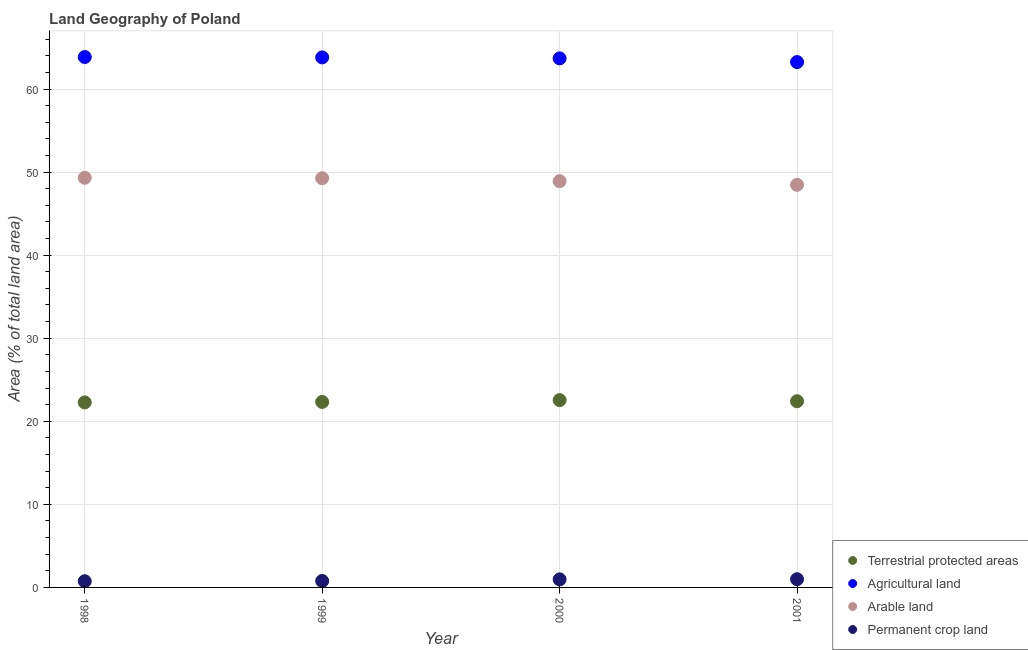How many different coloured dotlines are there?
Give a very brief answer. 4. Is the number of dotlines equal to the number of legend labels?
Your answer should be compact. Yes. What is the percentage of area under agricultural land in 1998?
Keep it short and to the point. 63.85. Across all years, what is the maximum percentage of area under arable land?
Your answer should be compact. 49.31. Across all years, what is the minimum percentage of area under permanent crop land?
Provide a short and direct response. 0.75. In which year was the percentage of area under permanent crop land maximum?
Your answer should be compact. 2001. What is the total percentage of area under agricultural land in the graph?
Provide a succinct answer. 254.59. What is the difference between the percentage of land under terrestrial protection in 1998 and that in 1999?
Offer a terse response. -0.06. What is the difference between the percentage of area under arable land in 2001 and the percentage of area under agricultural land in 1998?
Ensure brevity in your answer.  -15.39. What is the average percentage of area under arable land per year?
Keep it short and to the point. 48.99. In the year 2000, what is the difference between the percentage of area under arable land and percentage of area under permanent crop land?
Offer a terse response. 47.94. In how many years, is the percentage of area under permanent crop land greater than 58 %?
Your answer should be compact. 0. What is the ratio of the percentage of land under terrestrial protection in 1998 to that in 2000?
Your answer should be very brief. 0.99. Is the percentage of area under agricultural land in 1999 less than that in 2000?
Your answer should be compact. No. Is the difference between the percentage of land under terrestrial protection in 1998 and 2001 greater than the difference between the percentage of area under arable land in 1998 and 2001?
Your answer should be very brief. No. What is the difference between the highest and the second highest percentage of area under permanent crop land?
Offer a very short reply. 0.02. What is the difference between the highest and the lowest percentage of area under arable land?
Your answer should be very brief. 0.85. Is it the case that in every year, the sum of the percentage of land under terrestrial protection and percentage of area under arable land is greater than the sum of percentage of area under agricultural land and percentage of area under permanent crop land?
Make the answer very short. No. Is it the case that in every year, the sum of the percentage of land under terrestrial protection and percentage of area under agricultural land is greater than the percentage of area under arable land?
Offer a very short reply. Yes. Does the percentage of land under terrestrial protection monotonically increase over the years?
Offer a terse response. No. Is the percentage of land under terrestrial protection strictly less than the percentage of area under permanent crop land over the years?
Offer a very short reply. No. How many dotlines are there?
Provide a succinct answer. 4. What is the difference between two consecutive major ticks on the Y-axis?
Provide a succinct answer. 10. Does the graph contain any zero values?
Provide a short and direct response. No. What is the title of the graph?
Keep it short and to the point. Land Geography of Poland. What is the label or title of the X-axis?
Keep it short and to the point. Year. What is the label or title of the Y-axis?
Offer a terse response. Area (% of total land area). What is the Area (% of total land area) in Terrestrial protected areas in 1998?
Your response must be concise. 22.27. What is the Area (% of total land area) in Agricultural land in 1998?
Keep it short and to the point. 63.85. What is the Area (% of total land area) of Arable land in 1998?
Provide a short and direct response. 49.31. What is the Area (% of total land area) of Permanent crop land in 1998?
Give a very brief answer. 0.75. What is the Area (% of total land area) in Terrestrial protected areas in 1999?
Your response must be concise. 22.33. What is the Area (% of total land area) in Agricultural land in 1999?
Your answer should be compact. 63.81. What is the Area (% of total land area) of Arable land in 1999?
Ensure brevity in your answer.  49.26. What is the Area (% of total land area) in Permanent crop land in 1999?
Keep it short and to the point. 0.78. What is the Area (% of total land area) in Terrestrial protected areas in 2000?
Offer a very short reply. 22.55. What is the Area (% of total land area) of Agricultural land in 2000?
Your response must be concise. 63.69. What is the Area (% of total land area) in Arable land in 2000?
Your answer should be compact. 48.91. What is the Area (% of total land area) of Permanent crop land in 2000?
Your answer should be very brief. 0.97. What is the Area (% of total land area) in Terrestrial protected areas in 2001?
Ensure brevity in your answer.  22.41. What is the Area (% of total land area) in Agricultural land in 2001?
Offer a very short reply. 63.24. What is the Area (% of total land area) of Arable land in 2001?
Provide a succinct answer. 48.46. What is the Area (% of total land area) of Permanent crop land in 2001?
Your response must be concise. 0.99. Across all years, what is the maximum Area (% of total land area) of Terrestrial protected areas?
Your answer should be very brief. 22.55. Across all years, what is the maximum Area (% of total land area) in Agricultural land?
Offer a very short reply. 63.85. Across all years, what is the maximum Area (% of total land area) in Arable land?
Give a very brief answer. 49.31. Across all years, what is the maximum Area (% of total land area) of Permanent crop land?
Ensure brevity in your answer.  0.99. Across all years, what is the minimum Area (% of total land area) of Terrestrial protected areas?
Provide a short and direct response. 22.27. Across all years, what is the minimum Area (% of total land area) of Agricultural land?
Offer a very short reply. 63.24. Across all years, what is the minimum Area (% of total land area) of Arable land?
Your answer should be very brief. 48.46. Across all years, what is the minimum Area (% of total land area) in Permanent crop land?
Provide a short and direct response. 0.75. What is the total Area (% of total land area) of Terrestrial protected areas in the graph?
Ensure brevity in your answer.  89.57. What is the total Area (% of total land area) in Agricultural land in the graph?
Provide a succinct answer. 254.59. What is the total Area (% of total land area) of Arable land in the graph?
Offer a terse response. 195.94. What is the total Area (% of total land area) in Permanent crop land in the graph?
Provide a succinct answer. 3.48. What is the difference between the Area (% of total land area) of Terrestrial protected areas in 1998 and that in 1999?
Provide a short and direct response. -0.06. What is the difference between the Area (% of total land area) in Agricultural land in 1998 and that in 1999?
Give a very brief answer. 0.05. What is the difference between the Area (% of total land area) in Arable land in 1998 and that in 1999?
Your answer should be very brief. 0.05. What is the difference between the Area (% of total land area) in Permanent crop land in 1998 and that in 1999?
Give a very brief answer. -0.03. What is the difference between the Area (% of total land area) in Terrestrial protected areas in 1998 and that in 2000?
Make the answer very short. -0.28. What is the difference between the Area (% of total land area) in Agricultural land in 1998 and that in 2000?
Make the answer very short. 0.16. What is the difference between the Area (% of total land area) of Arable land in 1998 and that in 2000?
Keep it short and to the point. 0.4. What is the difference between the Area (% of total land area) in Permanent crop land in 1998 and that in 2000?
Your response must be concise. -0.22. What is the difference between the Area (% of total land area) in Terrestrial protected areas in 1998 and that in 2001?
Ensure brevity in your answer.  -0.14. What is the difference between the Area (% of total land area) of Agricultural land in 1998 and that in 2001?
Your answer should be very brief. 0.61. What is the difference between the Area (% of total land area) of Arable land in 1998 and that in 2001?
Provide a short and direct response. 0.85. What is the difference between the Area (% of total land area) in Permanent crop land in 1998 and that in 2001?
Provide a short and direct response. -0.24. What is the difference between the Area (% of total land area) of Terrestrial protected areas in 1999 and that in 2000?
Your response must be concise. -0.22. What is the difference between the Area (% of total land area) in Agricultural land in 1999 and that in 2000?
Provide a succinct answer. 0.11. What is the difference between the Area (% of total land area) of Arable land in 1999 and that in 2000?
Make the answer very short. 0.35. What is the difference between the Area (% of total land area) in Permanent crop land in 1999 and that in 2000?
Keep it short and to the point. -0.19. What is the difference between the Area (% of total land area) of Terrestrial protected areas in 1999 and that in 2001?
Your answer should be compact. -0.08. What is the difference between the Area (% of total land area) in Agricultural land in 1999 and that in 2001?
Provide a succinct answer. 0.56. What is the difference between the Area (% of total land area) in Arable land in 1999 and that in 2001?
Make the answer very short. 0.8. What is the difference between the Area (% of total land area) of Permanent crop land in 1999 and that in 2001?
Offer a very short reply. -0.21. What is the difference between the Area (% of total land area) in Terrestrial protected areas in 2000 and that in 2001?
Your response must be concise. 0.14. What is the difference between the Area (% of total land area) in Agricultural land in 2000 and that in 2001?
Make the answer very short. 0.45. What is the difference between the Area (% of total land area) of Arable land in 2000 and that in 2001?
Offer a very short reply. 0.44. What is the difference between the Area (% of total land area) in Permanent crop land in 2000 and that in 2001?
Your answer should be very brief. -0.02. What is the difference between the Area (% of total land area) in Terrestrial protected areas in 1998 and the Area (% of total land area) in Agricultural land in 1999?
Provide a short and direct response. -41.53. What is the difference between the Area (% of total land area) in Terrestrial protected areas in 1998 and the Area (% of total land area) in Arable land in 1999?
Keep it short and to the point. -26.99. What is the difference between the Area (% of total land area) of Terrestrial protected areas in 1998 and the Area (% of total land area) of Permanent crop land in 1999?
Your response must be concise. 21.5. What is the difference between the Area (% of total land area) of Agricultural land in 1998 and the Area (% of total land area) of Arable land in 1999?
Your response must be concise. 14.59. What is the difference between the Area (% of total land area) in Agricultural land in 1998 and the Area (% of total land area) in Permanent crop land in 1999?
Provide a short and direct response. 63.07. What is the difference between the Area (% of total land area) in Arable land in 1998 and the Area (% of total land area) in Permanent crop land in 1999?
Your answer should be compact. 48.54. What is the difference between the Area (% of total land area) of Terrestrial protected areas in 1998 and the Area (% of total land area) of Agricultural land in 2000?
Provide a short and direct response. -41.42. What is the difference between the Area (% of total land area) in Terrestrial protected areas in 1998 and the Area (% of total land area) in Arable land in 2000?
Offer a very short reply. -26.63. What is the difference between the Area (% of total land area) of Terrestrial protected areas in 1998 and the Area (% of total land area) of Permanent crop land in 2000?
Keep it short and to the point. 21.3. What is the difference between the Area (% of total land area) in Agricultural land in 1998 and the Area (% of total land area) in Arable land in 2000?
Make the answer very short. 14.94. What is the difference between the Area (% of total land area) of Agricultural land in 1998 and the Area (% of total land area) of Permanent crop land in 2000?
Your response must be concise. 62.88. What is the difference between the Area (% of total land area) of Arable land in 1998 and the Area (% of total land area) of Permanent crop land in 2000?
Provide a succinct answer. 48.34. What is the difference between the Area (% of total land area) of Terrestrial protected areas in 1998 and the Area (% of total land area) of Agricultural land in 2001?
Your response must be concise. -40.97. What is the difference between the Area (% of total land area) in Terrestrial protected areas in 1998 and the Area (% of total land area) in Arable land in 2001?
Offer a very short reply. -26.19. What is the difference between the Area (% of total land area) of Terrestrial protected areas in 1998 and the Area (% of total land area) of Permanent crop land in 2001?
Ensure brevity in your answer.  21.28. What is the difference between the Area (% of total land area) of Agricultural land in 1998 and the Area (% of total land area) of Arable land in 2001?
Your response must be concise. 15.39. What is the difference between the Area (% of total land area) in Agricultural land in 1998 and the Area (% of total land area) in Permanent crop land in 2001?
Your response must be concise. 62.86. What is the difference between the Area (% of total land area) in Arable land in 1998 and the Area (% of total land area) in Permanent crop land in 2001?
Your answer should be compact. 48.32. What is the difference between the Area (% of total land area) in Terrestrial protected areas in 1999 and the Area (% of total land area) in Agricultural land in 2000?
Keep it short and to the point. -41.36. What is the difference between the Area (% of total land area) in Terrestrial protected areas in 1999 and the Area (% of total land area) in Arable land in 2000?
Provide a succinct answer. -26.58. What is the difference between the Area (% of total land area) in Terrestrial protected areas in 1999 and the Area (% of total land area) in Permanent crop land in 2000?
Provide a succinct answer. 21.36. What is the difference between the Area (% of total land area) in Agricultural land in 1999 and the Area (% of total land area) in Arable land in 2000?
Your answer should be compact. 14.9. What is the difference between the Area (% of total land area) in Agricultural land in 1999 and the Area (% of total land area) in Permanent crop land in 2000?
Keep it short and to the point. 62.84. What is the difference between the Area (% of total land area) of Arable land in 1999 and the Area (% of total land area) of Permanent crop land in 2000?
Your answer should be compact. 48.29. What is the difference between the Area (% of total land area) of Terrestrial protected areas in 1999 and the Area (% of total land area) of Agricultural land in 2001?
Your answer should be very brief. -40.91. What is the difference between the Area (% of total land area) of Terrestrial protected areas in 1999 and the Area (% of total land area) of Arable land in 2001?
Ensure brevity in your answer.  -26.13. What is the difference between the Area (% of total land area) of Terrestrial protected areas in 1999 and the Area (% of total land area) of Permanent crop land in 2001?
Provide a short and direct response. 21.34. What is the difference between the Area (% of total land area) of Agricultural land in 1999 and the Area (% of total land area) of Arable land in 2001?
Provide a succinct answer. 15.34. What is the difference between the Area (% of total land area) in Agricultural land in 1999 and the Area (% of total land area) in Permanent crop land in 2001?
Offer a terse response. 62.82. What is the difference between the Area (% of total land area) of Arable land in 1999 and the Area (% of total land area) of Permanent crop land in 2001?
Make the answer very short. 48.27. What is the difference between the Area (% of total land area) in Terrestrial protected areas in 2000 and the Area (% of total land area) in Agricultural land in 2001?
Ensure brevity in your answer.  -40.69. What is the difference between the Area (% of total land area) in Terrestrial protected areas in 2000 and the Area (% of total land area) in Arable land in 2001?
Your answer should be very brief. -25.91. What is the difference between the Area (% of total land area) of Terrestrial protected areas in 2000 and the Area (% of total land area) of Permanent crop land in 2001?
Make the answer very short. 21.56. What is the difference between the Area (% of total land area) in Agricultural land in 2000 and the Area (% of total land area) in Arable land in 2001?
Your answer should be compact. 15.23. What is the difference between the Area (% of total land area) of Agricultural land in 2000 and the Area (% of total land area) of Permanent crop land in 2001?
Offer a terse response. 62.7. What is the difference between the Area (% of total land area) of Arable land in 2000 and the Area (% of total land area) of Permanent crop land in 2001?
Provide a short and direct response. 47.92. What is the average Area (% of total land area) of Terrestrial protected areas per year?
Offer a very short reply. 22.39. What is the average Area (% of total land area) in Agricultural land per year?
Your answer should be very brief. 63.65. What is the average Area (% of total land area) in Arable land per year?
Ensure brevity in your answer.  48.99. What is the average Area (% of total land area) of Permanent crop land per year?
Give a very brief answer. 0.87. In the year 1998, what is the difference between the Area (% of total land area) of Terrestrial protected areas and Area (% of total land area) of Agricultural land?
Offer a very short reply. -41.58. In the year 1998, what is the difference between the Area (% of total land area) in Terrestrial protected areas and Area (% of total land area) in Arable land?
Provide a short and direct response. -27.04. In the year 1998, what is the difference between the Area (% of total land area) in Terrestrial protected areas and Area (% of total land area) in Permanent crop land?
Make the answer very short. 21.53. In the year 1998, what is the difference between the Area (% of total land area) of Agricultural land and Area (% of total land area) of Arable land?
Provide a short and direct response. 14.54. In the year 1998, what is the difference between the Area (% of total land area) in Agricultural land and Area (% of total land area) in Permanent crop land?
Provide a short and direct response. 63.1. In the year 1998, what is the difference between the Area (% of total land area) in Arable land and Area (% of total land area) in Permanent crop land?
Make the answer very short. 48.57. In the year 1999, what is the difference between the Area (% of total land area) of Terrestrial protected areas and Area (% of total land area) of Agricultural land?
Your answer should be compact. -41.47. In the year 1999, what is the difference between the Area (% of total land area) in Terrestrial protected areas and Area (% of total land area) in Arable land?
Offer a terse response. -26.93. In the year 1999, what is the difference between the Area (% of total land area) in Terrestrial protected areas and Area (% of total land area) in Permanent crop land?
Provide a succinct answer. 21.55. In the year 1999, what is the difference between the Area (% of total land area) in Agricultural land and Area (% of total land area) in Arable land?
Provide a short and direct response. 14.54. In the year 1999, what is the difference between the Area (% of total land area) in Agricultural land and Area (% of total land area) in Permanent crop land?
Your answer should be compact. 63.03. In the year 1999, what is the difference between the Area (% of total land area) of Arable land and Area (% of total land area) of Permanent crop land?
Offer a very short reply. 48.48. In the year 2000, what is the difference between the Area (% of total land area) in Terrestrial protected areas and Area (% of total land area) in Agricultural land?
Ensure brevity in your answer.  -41.14. In the year 2000, what is the difference between the Area (% of total land area) in Terrestrial protected areas and Area (% of total land area) in Arable land?
Offer a very short reply. -26.36. In the year 2000, what is the difference between the Area (% of total land area) in Terrestrial protected areas and Area (% of total land area) in Permanent crop land?
Make the answer very short. 21.58. In the year 2000, what is the difference between the Area (% of total land area) of Agricultural land and Area (% of total land area) of Arable land?
Provide a succinct answer. 14.78. In the year 2000, what is the difference between the Area (% of total land area) of Agricultural land and Area (% of total land area) of Permanent crop land?
Ensure brevity in your answer.  62.72. In the year 2000, what is the difference between the Area (% of total land area) in Arable land and Area (% of total land area) in Permanent crop land?
Make the answer very short. 47.94. In the year 2001, what is the difference between the Area (% of total land area) of Terrestrial protected areas and Area (% of total land area) of Agricultural land?
Make the answer very short. -40.83. In the year 2001, what is the difference between the Area (% of total land area) of Terrestrial protected areas and Area (% of total land area) of Arable land?
Your response must be concise. -26.05. In the year 2001, what is the difference between the Area (% of total land area) in Terrestrial protected areas and Area (% of total land area) in Permanent crop land?
Your response must be concise. 21.42. In the year 2001, what is the difference between the Area (% of total land area) of Agricultural land and Area (% of total land area) of Arable land?
Provide a succinct answer. 14.78. In the year 2001, what is the difference between the Area (% of total land area) of Agricultural land and Area (% of total land area) of Permanent crop land?
Your response must be concise. 62.25. In the year 2001, what is the difference between the Area (% of total land area) of Arable land and Area (% of total land area) of Permanent crop land?
Offer a very short reply. 47.47. What is the ratio of the Area (% of total land area) of Permanent crop land in 1998 to that in 1999?
Provide a succinct answer. 0.96. What is the ratio of the Area (% of total land area) of Agricultural land in 1998 to that in 2000?
Your answer should be compact. 1. What is the ratio of the Area (% of total land area) in Arable land in 1998 to that in 2000?
Your answer should be very brief. 1.01. What is the ratio of the Area (% of total land area) of Permanent crop land in 1998 to that in 2000?
Your answer should be compact. 0.77. What is the ratio of the Area (% of total land area) of Agricultural land in 1998 to that in 2001?
Keep it short and to the point. 1.01. What is the ratio of the Area (% of total land area) in Arable land in 1998 to that in 2001?
Make the answer very short. 1.02. What is the ratio of the Area (% of total land area) of Permanent crop land in 1998 to that in 2001?
Offer a terse response. 0.76. What is the ratio of the Area (% of total land area) of Terrestrial protected areas in 1999 to that in 2000?
Make the answer very short. 0.99. What is the ratio of the Area (% of total land area) of Arable land in 1999 to that in 2000?
Provide a short and direct response. 1.01. What is the ratio of the Area (% of total land area) of Permanent crop land in 1999 to that in 2000?
Your answer should be compact. 0.8. What is the ratio of the Area (% of total land area) of Agricultural land in 1999 to that in 2001?
Your answer should be very brief. 1.01. What is the ratio of the Area (% of total land area) of Arable land in 1999 to that in 2001?
Give a very brief answer. 1.02. What is the ratio of the Area (% of total land area) of Permanent crop land in 1999 to that in 2001?
Give a very brief answer. 0.79. What is the ratio of the Area (% of total land area) in Agricultural land in 2000 to that in 2001?
Your answer should be compact. 1.01. What is the ratio of the Area (% of total land area) of Arable land in 2000 to that in 2001?
Offer a terse response. 1.01. What is the ratio of the Area (% of total land area) in Permanent crop land in 2000 to that in 2001?
Provide a succinct answer. 0.98. What is the difference between the highest and the second highest Area (% of total land area) of Terrestrial protected areas?
Your answer should be compact. 0.14. What is the difference between the highest and the second highest Area (% of total land area) in Agricultural land?
Your answer should be very brief. 0.05. What is the difference between the highest and the second highest Area (% of total land area) of Arable land?
Keep it short and to the point. 0.05. What is the difference between the highest and the second highest Area (% of total land area) of Permanent crop land?
Your answer should be compact. 0.02. What is the difference between the highest and the lowest Area (% of total land area) in Terrestrial protected areas?
Your answer should be compact. 0.28. What is the difference between the highest and the lowest Area (% of total land area) of Agricultural land?
Provide a succinct answer. 0.61. What is the difference between the highest and the lowest Area (% of total land area) in Arable land?
Provide a short and direct response. 0.85. What is the difference between the highest and the lowest Area (% of total land area) in Permanent crop land?
Give a very brief answer. 0.24. 